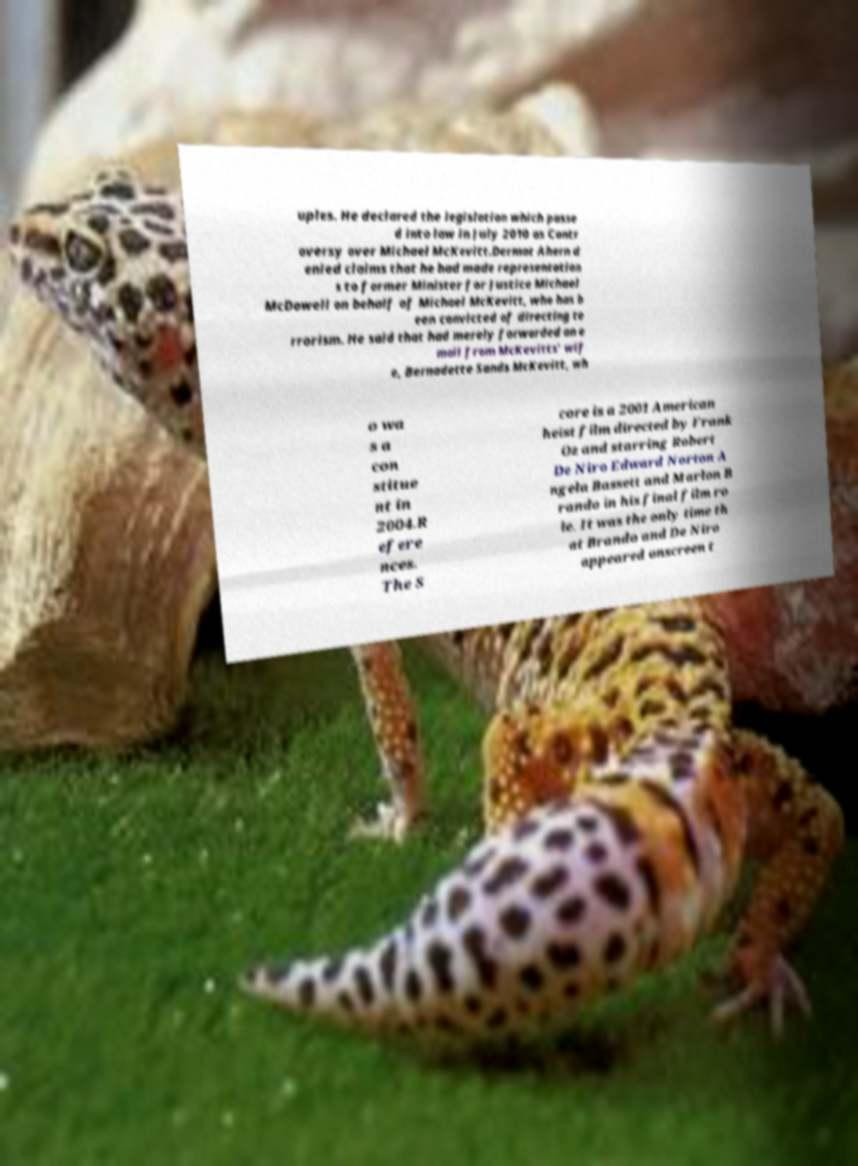What messages or text are displayed in this image? I need them in a readable, typed format. uples. He declared the legislation which passe d into law in July 2010 as Contr oversy over Michael McKevitt.Dermot Ahern d enied claims that he had made representation s to former Minister for Justice Michael McDowell on behalf of Michael McKevitt, who has b een convicted of directing te rrorism. He said that had merely forwarded an e mail from McKevitts' wif e, Bernadette Sands McKevitt, wh o wa s a con stitue nt in 2004.R efere nces. The S core is a 2001 American heist film directed by Frank Oz and starring Robert De Niro Edward Norton A ngela Bassett and Marlon B rando in his final film ro le. It was the only time th at Brando and De Niro appeared onscreen t 